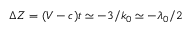Convert formula to latex. <formula><loc_0><loc_0><loc_500><loc_500>\Delta Z = ( V - c ) t \simeq - 3 / k _ { 0 } \simeq - \lambda _ { 0 } / 2</formula> 